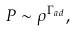Convert formula to latex. <formula><loc_0><loc_0><loc_500><loc_500>P \sim \rho ^ { \Gamma _ { a d } } ,</formula> 